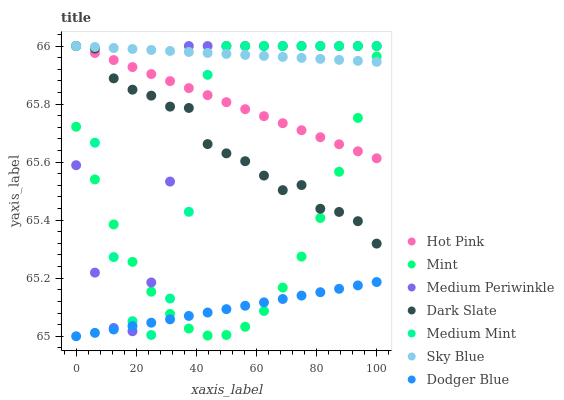Does Dodger Blue have the minimum area under the curve?
Answer yes or no. Yes. Does Sky Blue have the maximum area under the curve?
Answer yes or no. Yes. Does Hot Pink have the minimum area under the curve?
Answer yes or no. No. Does Hot Pink have the maximum area under the curve?
Answer yes or no. No. Is Dodger Blue the smoothest?
Answer yes or no. Yes. Is Medium Mint the roughest?
Answer yes or no. Yes. Is Hot Pink the smoothest?
Answer yes or no. No. Is Hot Pink the roughest?
Answer yes or no. No. Does Dodger Blue have the lowest value?
Answer yes or no. Yes. Does Hot Pink have the lowest value?
Answer yes or no. No. Does Sky Blue have the highest value?
Answer yes or no. Yes. Does Dodger Blue have the highest value?
Answer yes or no. No. Is Dodger Blue less than Dark Slate?
Answer yes or no. Yes. Is Sky Blue greater than Dodger Blue?
Answer yes or no. Yes. Does Medium Mint intersect Hot Pink?
Answer yes or no. Yes. Is Medium Mint less than Hot Pink?
Answer yes or no. No. Is Medium Mint greater than Hot Pink?
Answer yes or no. No. Does Dodger Blue intersect Dark Slate?
Answer yes or no. No. 